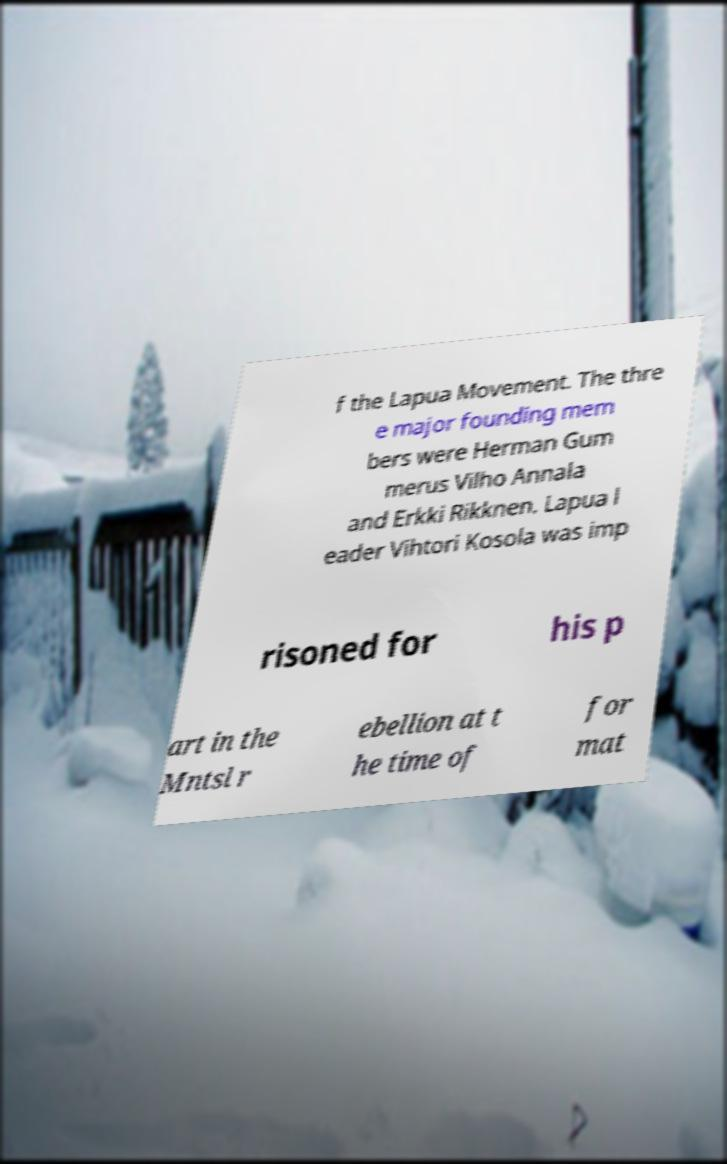Can you accurately transcribe the text from the provided image for me? f the Lapua Movement. The thre e major founding mem bers were Herman Gum merus Vilho Annala and Erkki Rikknen. Lapua l eader Vihtori Kosola was imp risoned for his p art in the Mntsl r ebellion at t he time of for mat 